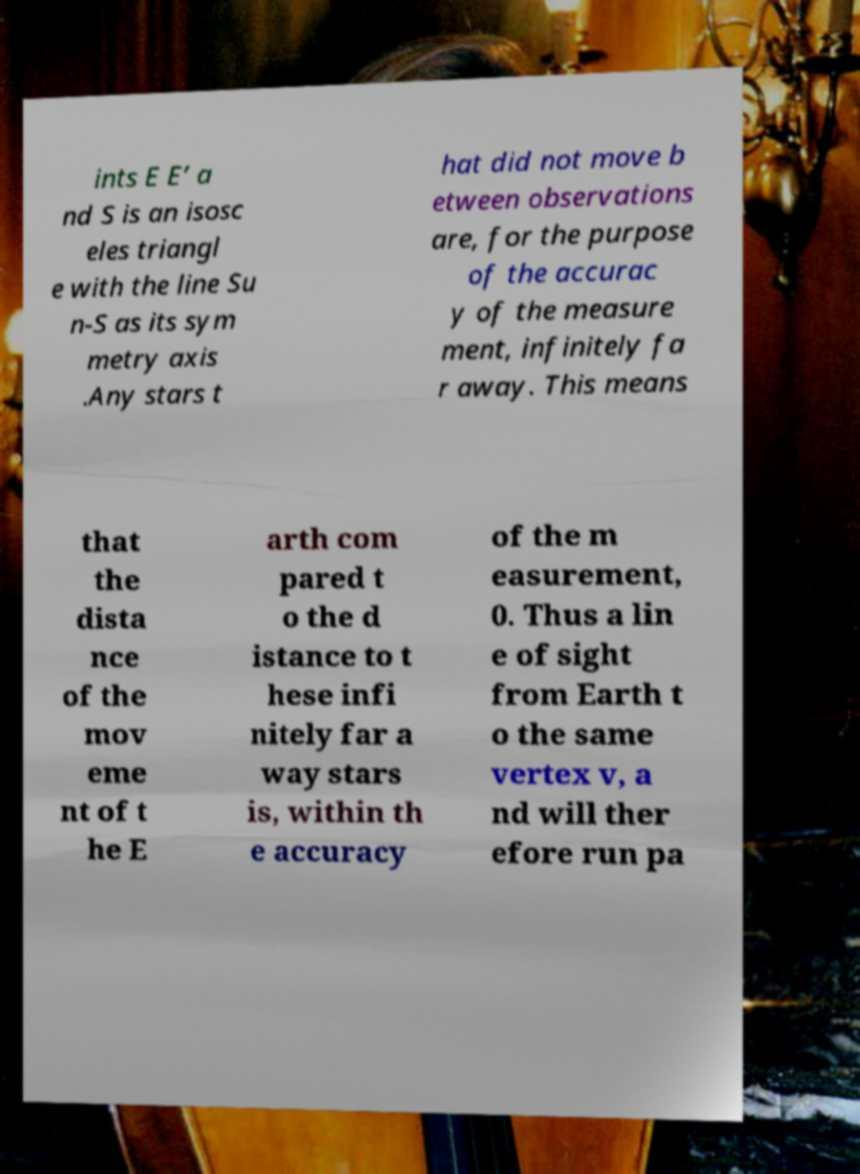There's text embedded in this image that I need extracted. Can you transcribe it verbatim? ints E E’ a nd S is an isosc eles triangl e with the line Su n-S as its sym metry axis .Any stars t hat did not move b etween observations are, for the purpose of the accurac y of the measure ment, infinitely fa r away. This means that the dista nce of the mov eme nt of t he E arth com pared t o the d istance to t hese infi nitely far a way stars is, within th e accuracy of the m easurement, 0. Thus a lin e of sight from Earth t o the same vertex v, a nd will ther efore run pa 